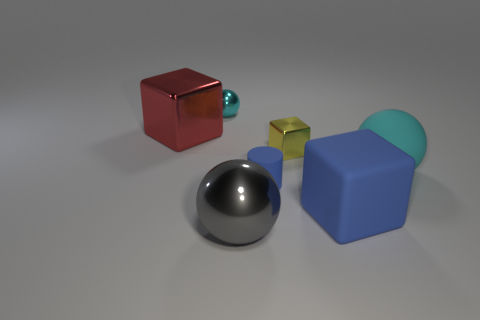Subtract all brown cubes. How many cyan spheres are left? 2 Subtract all large blocks. How many blocks are left? 1 Add 1 small cyan metallic spheres. How many objects exist? 8 Subtract 1 balls. How many balls are left? 2 Subtract all balls. How many objects are left? 4 Subtract all big blue matte objects. Subtract all tiny cylinders. How many objects are left? 5 Add 6 cyan spheres. How many cyan spheres are left? 8 Add 3 tiny blue cylinders. How many tiny blue cylinders exist? 4 Subtract 0 cyan blocks. How many objects are left? 7 Subtract all cyan cubes. Subtract all gray balls. How many cubes are left? 3 